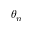<formula> <loc_0><loc_0><loc_500><loc_500>\theta _ { n }</formula> 